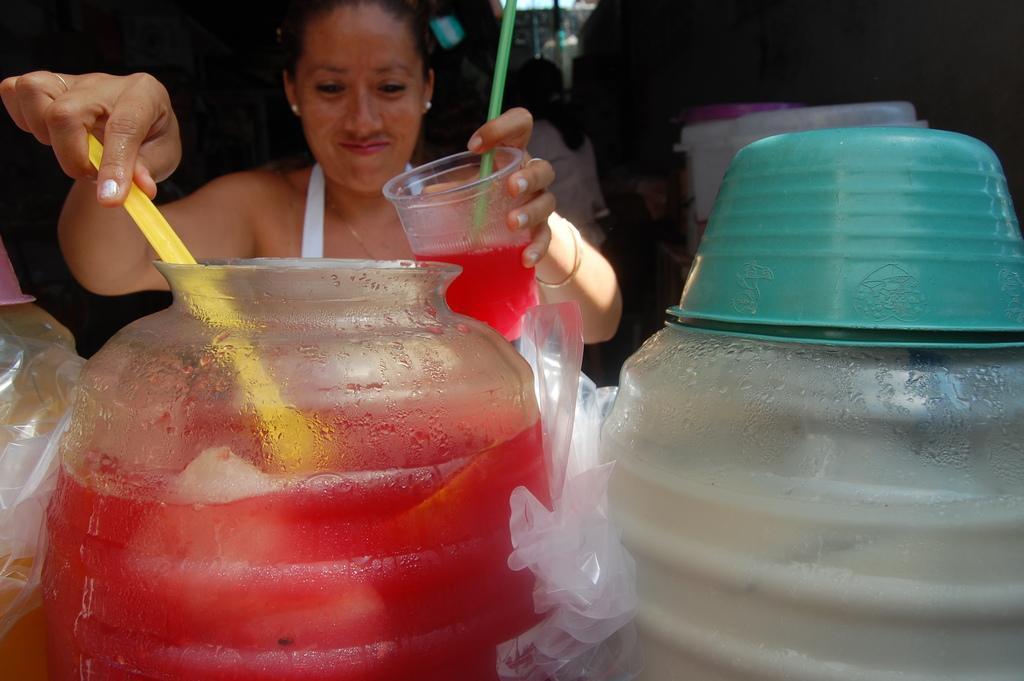In one or two sentences, can you explain what this image depicts? In the picture we can see a woman standing near the jar holding a yellow spoon and serving in the glass which she is holding in the other hand and beside the jar we can see some other jars and behind her we can see some people are standing in the dark. 